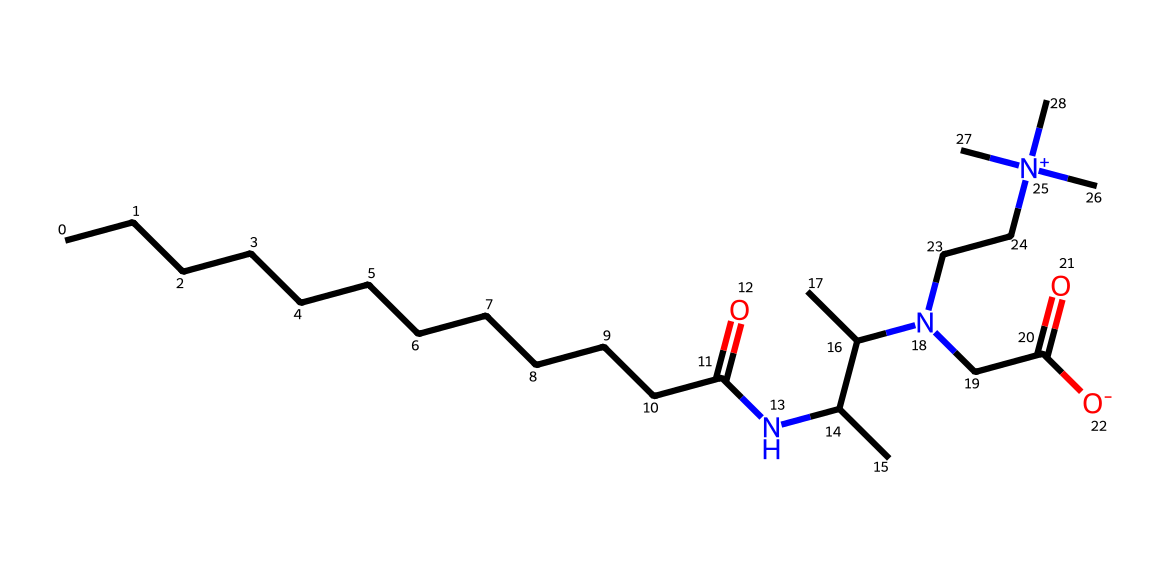What is the molecular formula of cocamidopropyl betaine? The molecular formula can be derived from counting each type of atom in the SMILES representation. In the chemical structure given, we count the carbon (C), hydrogen (H), oxygen (O), and nitrogen (N) atoms. The total yields C15H30N2O2.
Answer: C15H30N2O2 How many nitrogen atoms are present in this chemical? By inspecting the SMILES structure, we identify the nitrogen symbols (N) present in the molecule. There are two nitrogen atoms in the structure.
Answer: 2 What functional groups are present in cocamidopropyl betaine? We look for identifiable groups based on the SMILES notation. Notably, there is an amide group (indicated by the carbonyl adjacent to a nitrogen) and a quaternary ammonium group (the nitrogen atom connected to four carbons). This indicates the presence of both an amide and a quaternary ammonium functional group.
Answer: amide, quaternary ammonium Is cocamidopropyl betaine ionic or non-ionic? The structure shows the presence of a quaternary nitrogen, which carries a positive charge, indicating an ionic character. Non-ionic surfactants do not carry any charge. Thus, the presence of this charged species results in an ionic classification.
Answer: ionic What property makes cocamidopropyl betaine a mild surfactant? The presence of both hydrophobic (long carbon chains) and hydrophilic (the betaine group with a charged nitrogen) components contributes to mild surfactant properties. This balance allows for good cleaning without harsh effects.
Answer: balance of hydrophobic and hydrophilic components What is the role of the carbon chain in cocamidopropyl betaine? The long carbon chain increases the hydrophobic nature of the molecule, which is essential for its function as a surfactant. It enhances the ability to interact with oils and dirt, allowing effective cleaning.
Answer: increases hydrophobic nature 